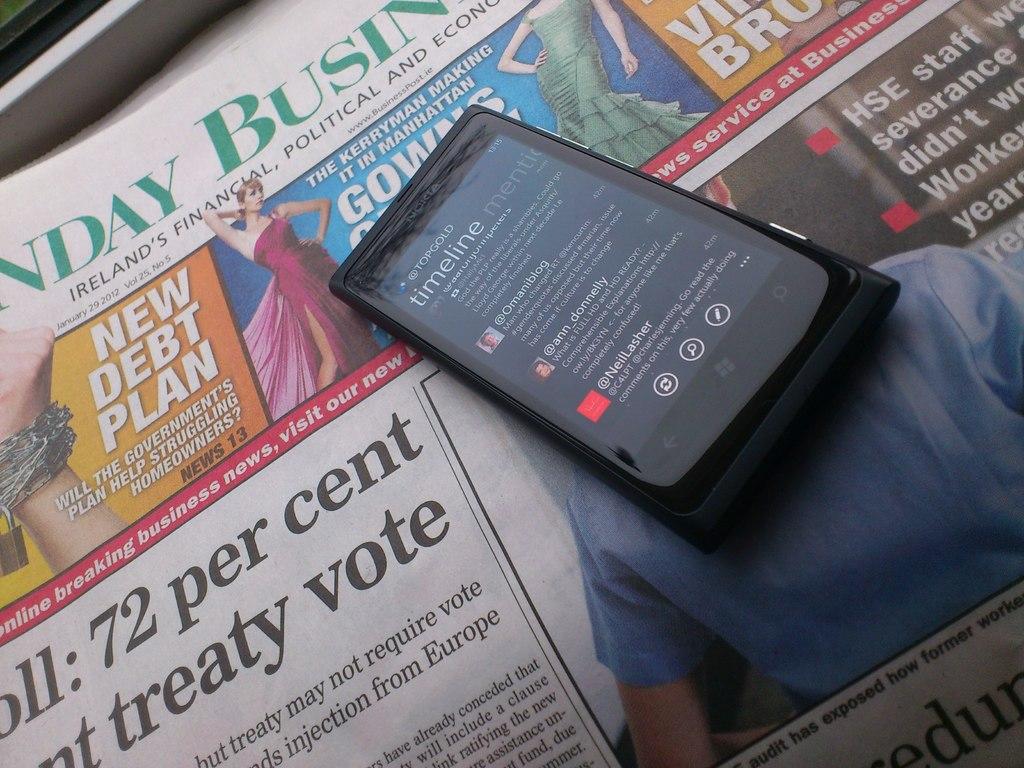What country's paper is this?
Your answer should be very brief. Ireland. What was the percent on the treaty vote?
Keep it short and to the point. 72. 